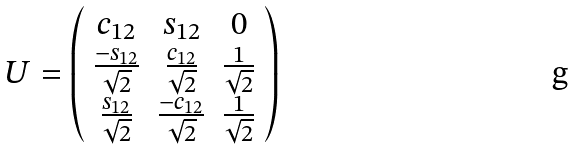Convert formula to latex. <formula><loc_0><loc_0><loc_500><loc_500>U = \left ( \begin{array} { c c c } c _ { 1 2 } & s _ { 1 2 } & 0 \\ \frac { - s _ { 1 2 } } { \sqrt { 2 } } & \frac { c _ { 1 2 } } { \sqrt { 2 } } & \frac { 1 } { \sqrt { 2 } } \\ \frac { s _ { 1 2 } } { \sqrt { 2 } } & \frac { - c _ { 1 2 } } { \sqrt { 2 } } & \frac { 1 } { \sqrt { 2 } } \\ \end{array} \right )</formula> 